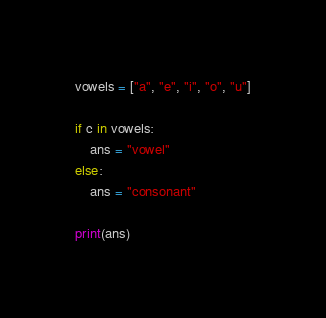<code> <loc_0><loc_0><loc_500><loc_500><_Python_>vowels = ["a", "e", "i", "o", "u"]

if c in vowels:
    ans = "vowel"
else:
    ans = "consonant"

print(ans)
</code> 